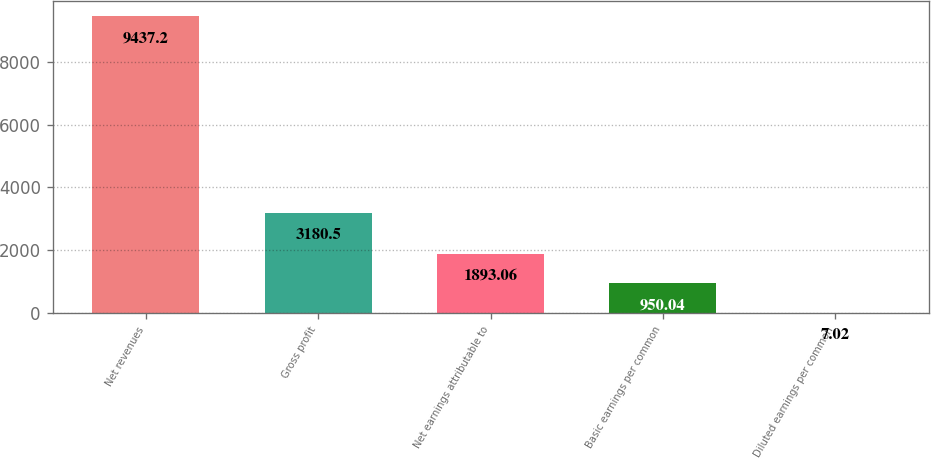<chart> <loc_0><loc_0><loc_500><loc_500><bar_chart><fcel>Net revenues<fcel>Gross profit<fcel>Net earnings attributable to<fcel>Basic earnings per common<fcel>Diluted earnings per common<nl><fcel>9437.2<fcel>3180.5<fcel>1893.06<fcel>950.04<fcel>7.02<nl></chart> 